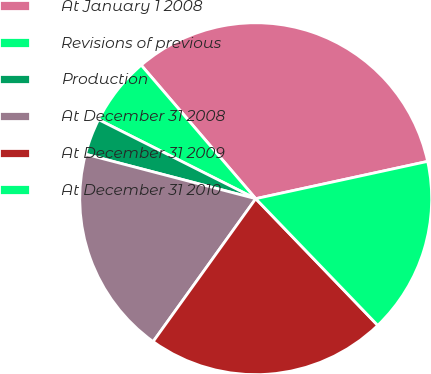Convert chart to OTSL. <chart><loc_0><loc_0><loc_500><loc_500><pie_chart><fcel>At January 1 2008<fcel>Revisions of previous<fcel>Production<fcel>At December 31 2008<fcel>At December 31 2009<fcel>At December 31 2010<nl><fcel>32.88%<fcel>6.3%<fcel>3.35%<fcel>19.16%<fcel>22.11%<fcel>16.2%<nl></chart> 